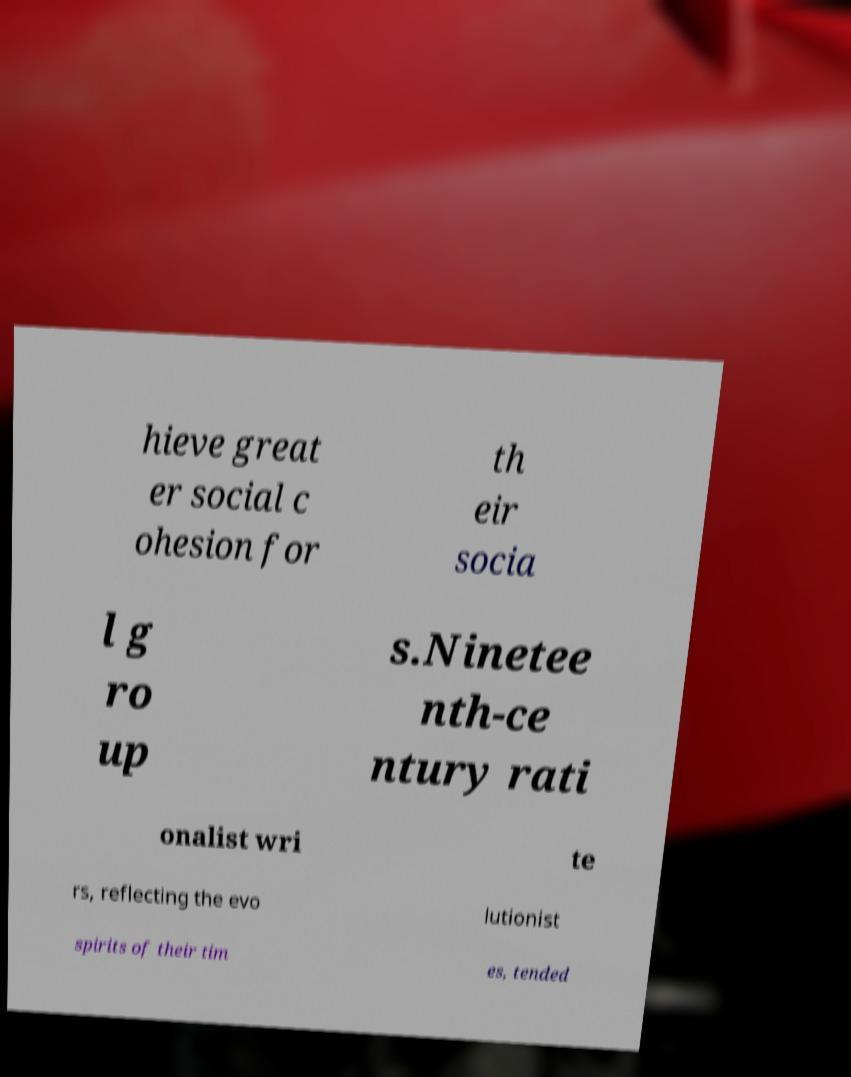Please identify and transcribe the text found in this image. hieve great er social c ohesion for th eir socia l g ro up s.Ninetee nth-ce ntury rati onalist wri te rs, reflecting the evo lutionist spirits of their tim es, tended 